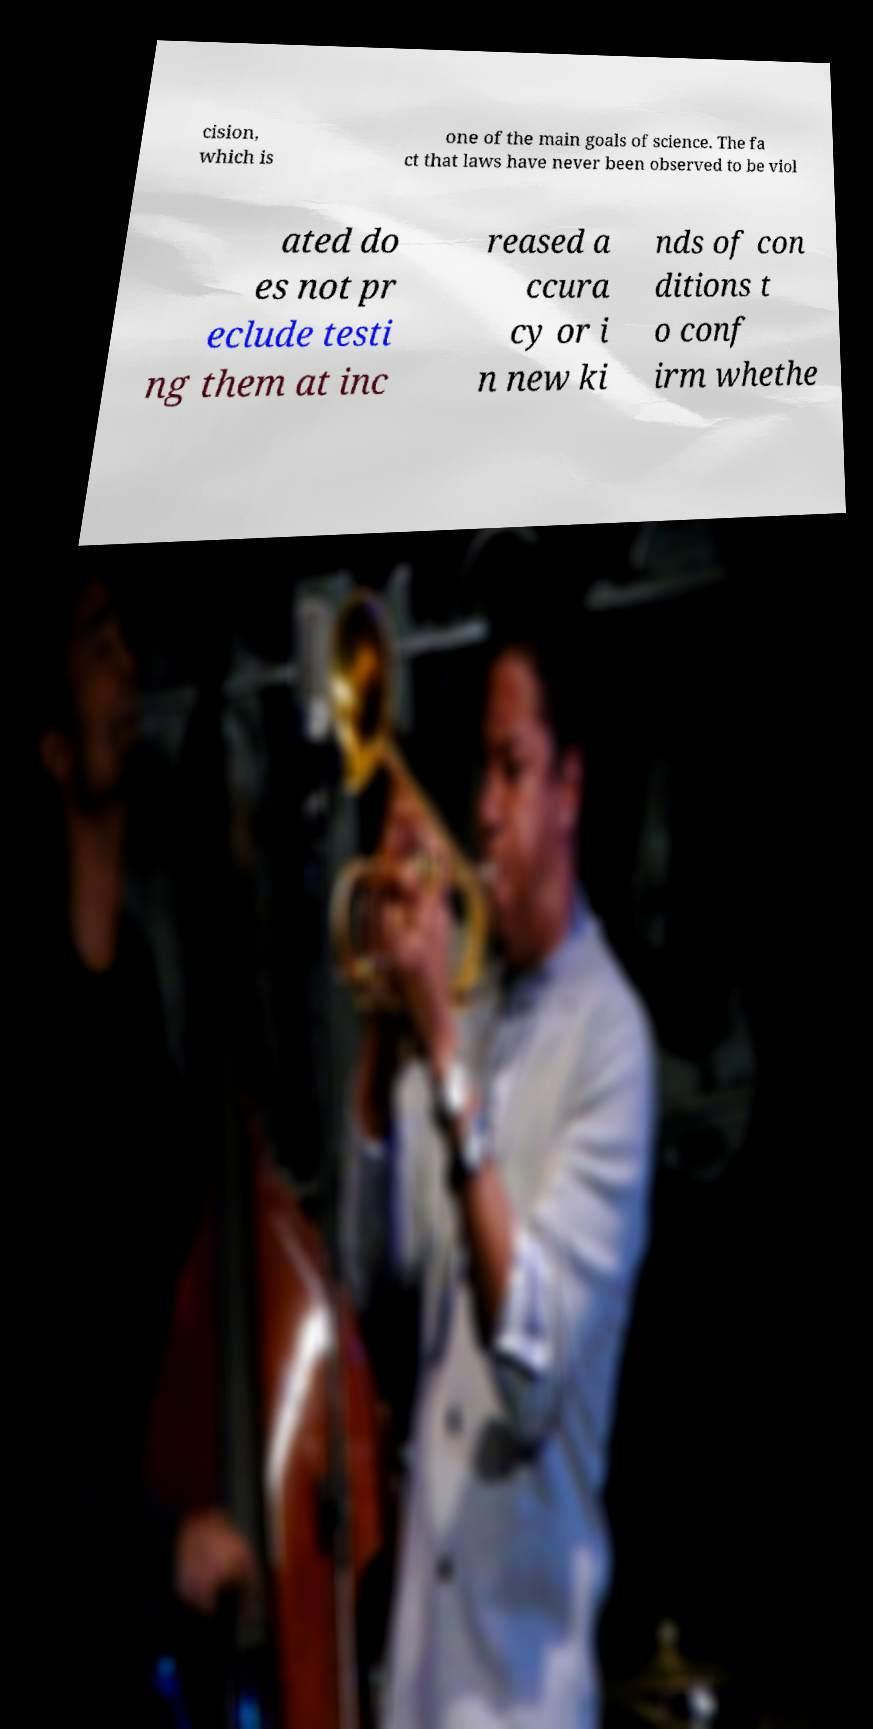Can you read and provide the text displayed in the image?This photo seems to have some interesting text. Can you extract and type it out for me? cision, which is one of the main goals of science. The fa ct that laws have never been observed to be viol ated do es not pr eclude testi ng them at inc reased a ccura cy or i n new ki nds of con ditions t o conf irm whethe 